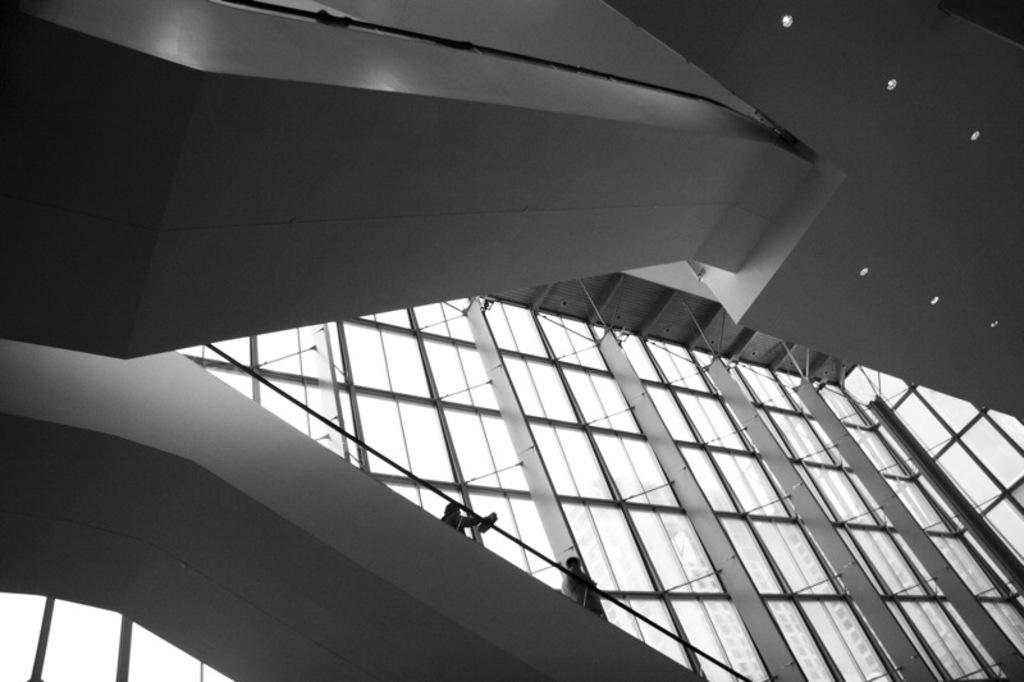What type of location is depicted in the image? The image shows an inner view of a building. How many people are inside the building? There are two people inside the building. What can be seen inside the building? There are lights visible inside the building. What architectural feature allows natural light to enter the building? There are windows in the building. What can be seen through the windows? Other buildings are visible through the windows. What type of frog can be seen sitting on the sign outside the building? There is no frog or sign present outside the building in the image. 